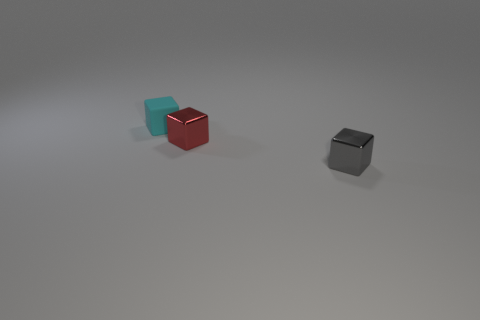Is the cyan block made of the same material as the red block that is behind the gray object?
Your answer should be compact. No. Are there more cubes behind the red metal block than objects that are to the right of the tiny gray thing?
Ensure brevity in your answer.  Yes. The cyan thing is what shape?
Your answer should be compact. Cube. Does the small object in front of the small red thing have the same material as the tiny cube that is to the left of the red shiny cube?
Offer a very short reply. No. What is the shape of the metallic thing that is left of the gray shiny object?
Offer a terse response. Cube. What is the size of the red metallic object that is the same shape as the gray metallic thing?
Your answer should be very brief. Small. Is there any other thing that is the same shape as the small cyan rubber thing?
Provide a short and direct response. Yes. There is a object that is to the right of the red shiny object; is there a small block behind it?
Your answer should be compact. Yes. There is another small matte object that is the same shape as the gray thing; what is its color?
Your response must be concise. Cyan. What is the color of the small metallic object that is on the right side of the shiny block that is behind the shiny object that is on the right side of the small red metal block?
Provide a short and direct response. Gray. 